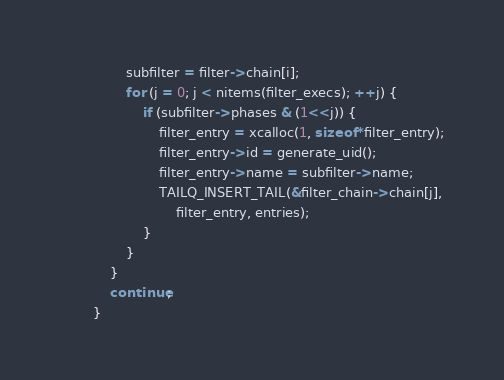<code> <loc_0><loc_0><loc_500><loc_500><_C_>				subfilter = filter->chain[i];
				for (j = 0; j < nitems(filter_execs); ++j) {
					if (subfilter->phases & (1<<j)) {
						filter_entry = xcalloc(1, sizeof *filter_entry);
						filter_entry->id = generate_uid();
						filter_entry->name = subfilter->name;
						TAILQ_INSERT_TAIL(&filter_chain->chain[j],
						    filter_entry, entries);
					}
				}
			}
			continue;
		}
</code> 